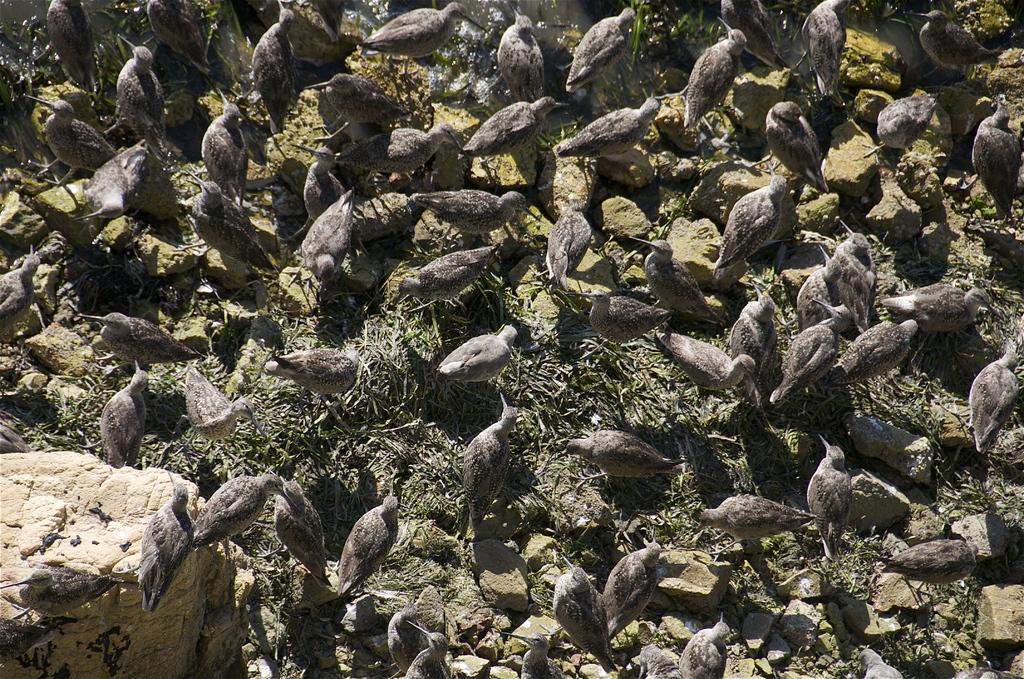What type of animals can be seen in the image? There are birds in the image. What colors are the birds? The birds have brown and white colors. What other object is present in the image? There is a rock in the image. What type of iron can be seen in the image? There is no iron present in the image; it features birds and a rock. Where is the market located in the image? There is no market present in the image. 